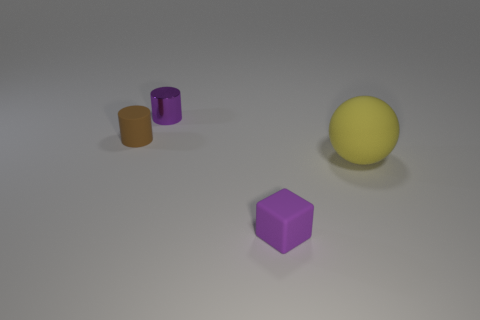How many objects are in front of the tiny purple cylinder and to the right of the tiny brown matte object?
Give a very brief answer. 2. There is a purple thing that is made of the same material as the brown cylinder; what size is it?
Provide a succinct answer. Small. The purple cube is what size?
Ensure brevity in your answer.  Small. What is the big sphere made of?
Provide a short and direct response. Rubber. There is a purple object that is in front of the brown thing; does it have the same size as the big yellow sphere?
Your response must be concise. No. What number of objects are big yellow metal objects or small cylinders?
Provide a succinct answer. 2. There is a tiny object that is the same color as the rubber cube; what is its shape?
Keep it short and to the point. Cylinder. What is the size of the matte object that is both left of the large ball and right of the brown cylinder?
Provide a short and direct response. Small. How many small cyan spheres are there?
Provide a succinct answer. 0. How many cylinders are either large objects or small purple rubber objects?
Provide a succinct answer. 0. 